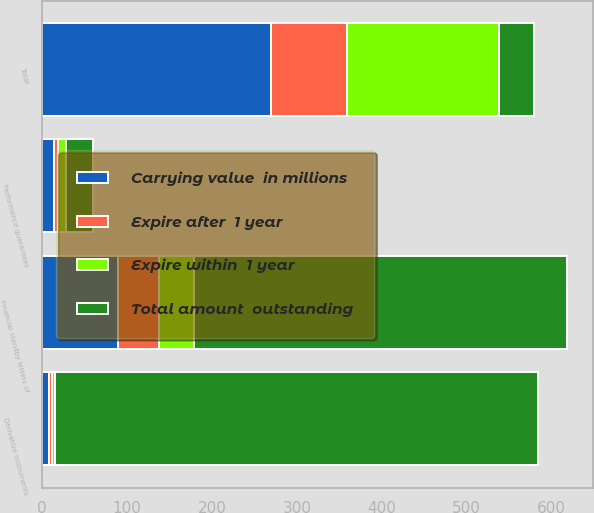<chart> <loc_0><loc_0><loc_500><loc_500><stacked_bar_chart><ecel><fcel>Financial standby letters of<fcel>Performance guarantees<fcel>Derivative instruments<fcel>Total<nl><fcel>Expire within  1 year<fcel>41.4<fcel>9.4<fcel>4.1<fcel>179.1<nl><fcel>Expire after  1 year<fcel>48<fcel>4.5<fcel>3.6<fcel>89.9<nl><fcel>Carrying value  in millions<fcel>89.4<fcel>13.9<fcel>7.7<fcel>269<nl><fcel>Total amount  outstanding<fcel>438.8<fcel>32.4<fcel>569.2<fcel>41.4<nl></chart> 